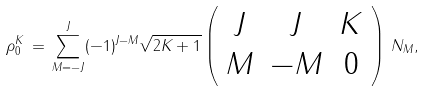Convert formula to latex. <formula><loc_0><loc_0><loc_500><loc_500>\rho ^ { K } _ { 0 } \, = \, \sum _ { M = - J } ^ { J } ( - 1 ) ^ { J - M } \sqrt { 2 K + 1 } \left ( \begin{array} { c c c } J & J & K \\ M & - M & 0 \end{array} \right ) \, { N _ { M } } ,</formula> 